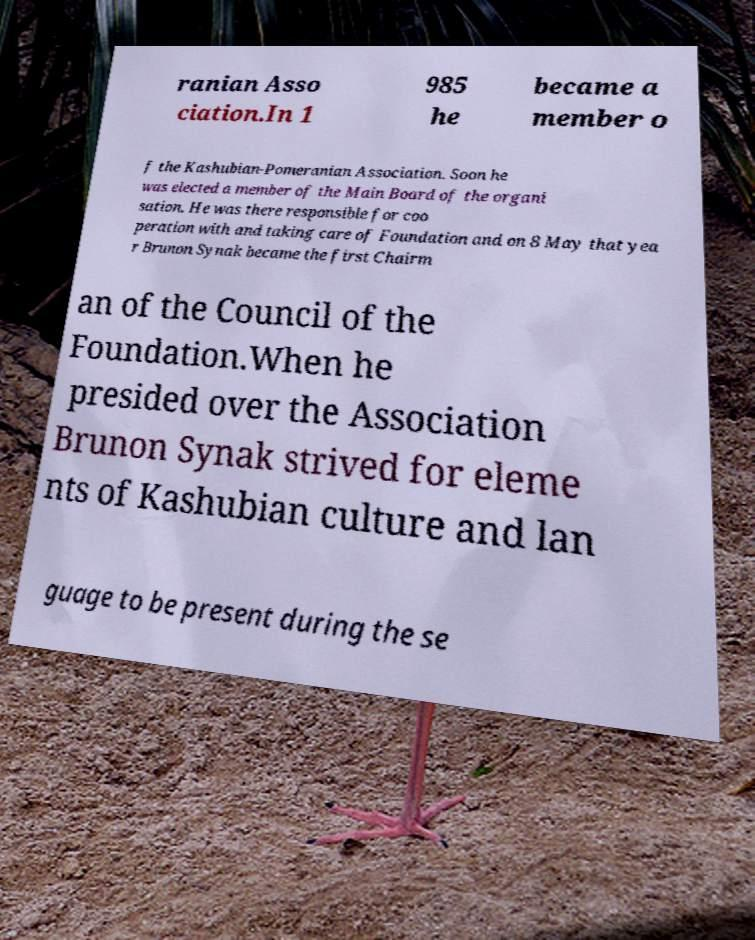Could you extract and type out the text from this image? ranian Asso ciation.In 1 985 he became a member o f the Kashubian-Pomeranian Association. Soon he was elected a member of the Main Board of the organi sation. He was there responsible for coo peration with and taking care of Foundation and on 8 May that yea r Brunon Synak became the first Chairm an of the Council of the Foundation.When he presided over the Association Brunon Synak strived for eleme nts of Kashubian culture and lan guage to be present during the se 